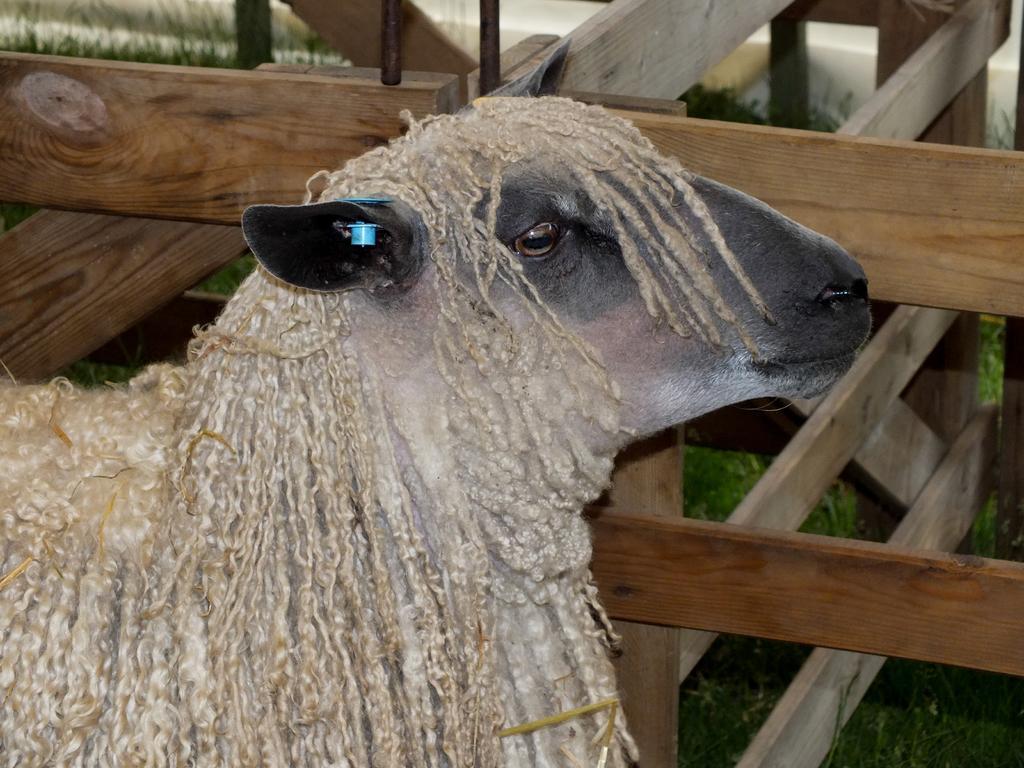Could you give a brief overview of what you see in this image? In this image in the foreground there is one animal, and in the background there is a fence and grass. 